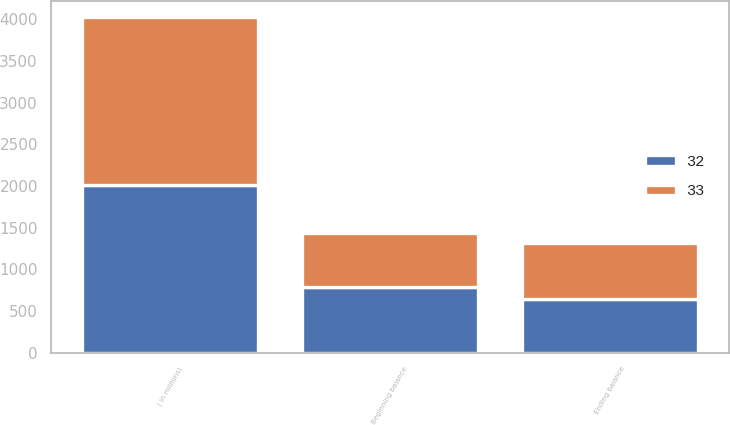Convert chart. <chart><loc_0><loc_0><loc_500><loc_500><stacked_bar_chart><ecel><fcel>( in millions)<fcel>Beginning balance<fcel>Ending balance<nl><fcel>33<fcel>2012<fcel>649<fcel>664<nl><fcel>32<fcel>2011<fcel>791<fcel>649<nl></chart> 